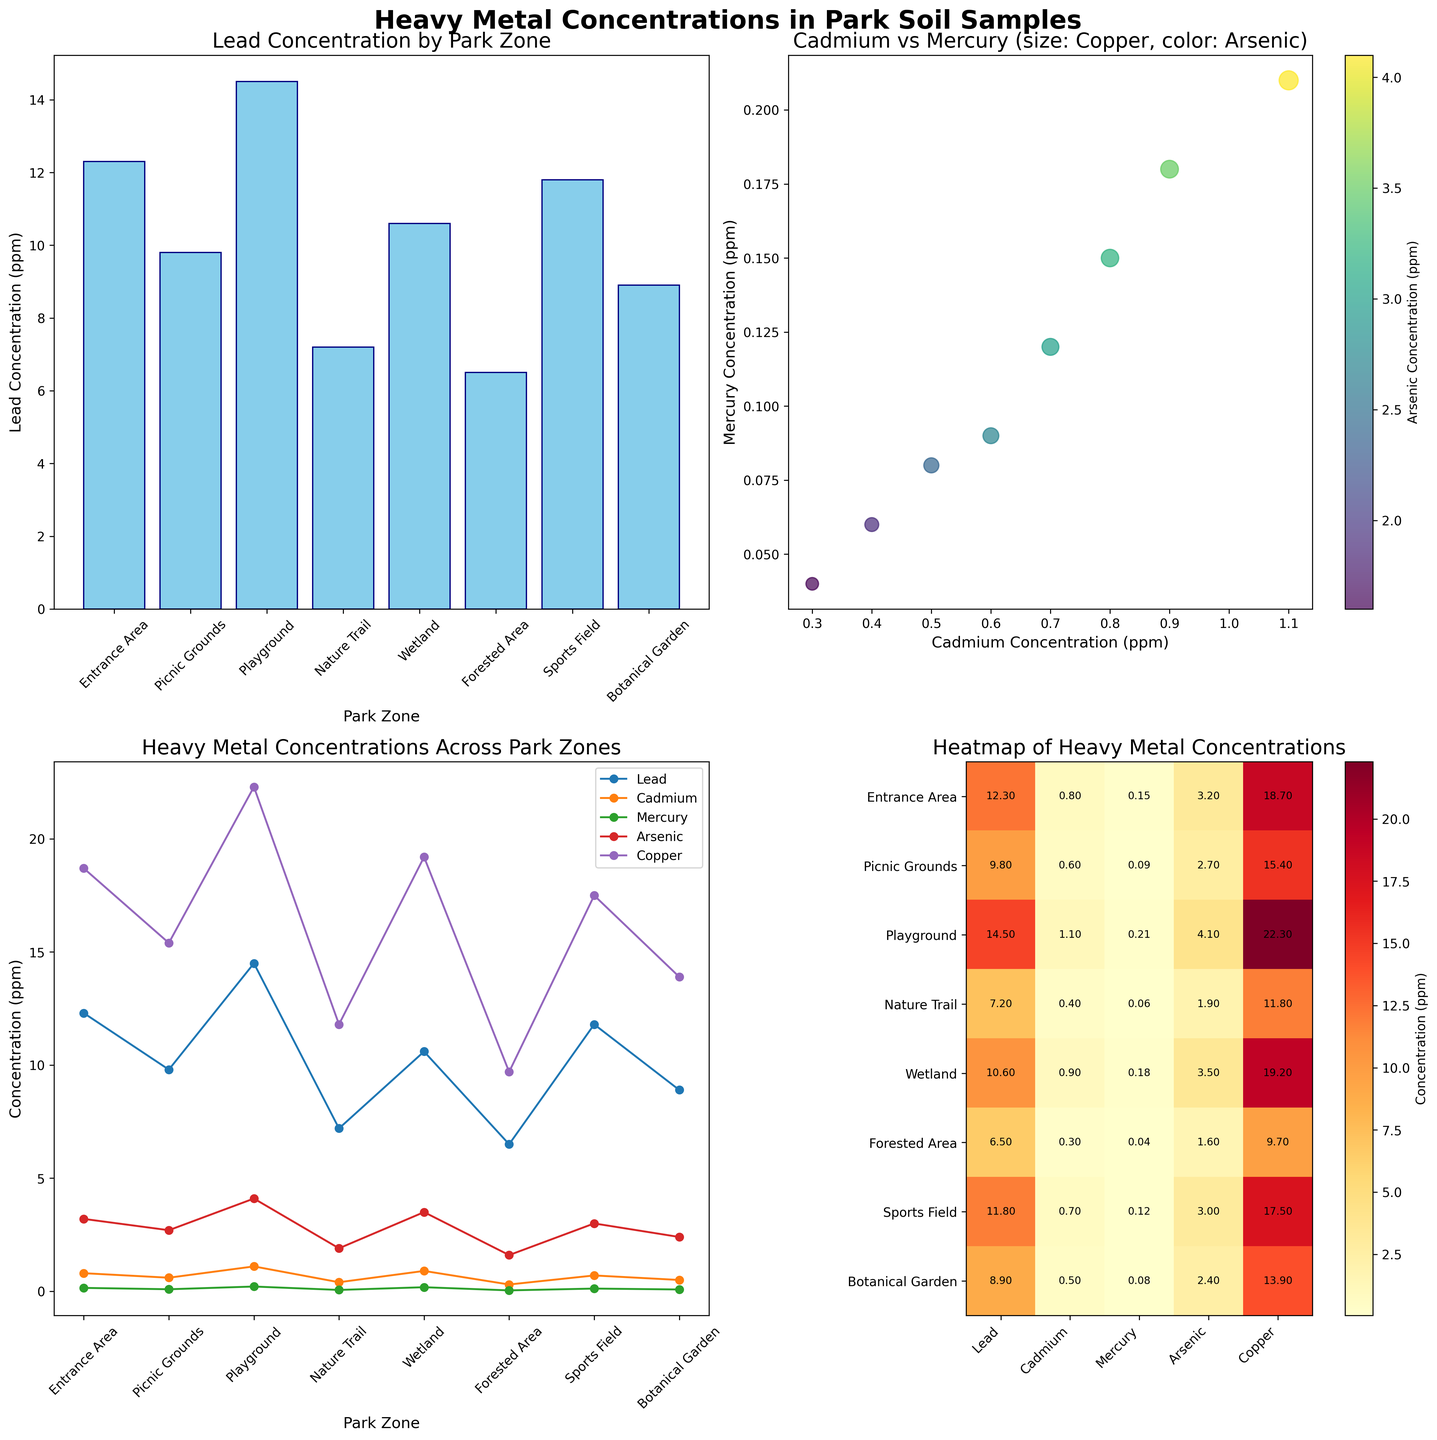what is the title of the top left subplot? The title of the top left subplot is placed at the top of the chart, within that subplot’s frame. It reads 'Lead Concentration by Park Zone'.
Answer: Lead Concentration by Park Zone Which park zone has the highest lead concentration? From the bar plot in the top left subplot, we see that the Playground has the tallest bar indicating it has the highest value.
Answer: Playground What are the x-axis labels of the heatmap in the bottom right subplot? The x-axis labels of the heatmap, representing different heavy metals, are displayed along the bottom axis. They read as Lead, Cadmium, Mercury, Arsenic, and Copper.
Answer: Lead, Cadmium, Mercury, Arsenic, Copper What is the range of arsenic concentration across all park zones? In the scatter plot at the top right, the color bar represents the arsenic concentration. Checking the color scale and the points on the scatter plot, we can infer that arsenic concentrations range from around 1.6 to 4.1 ppm.
Answer: 1.6 to 4.1 ppm Which two zones have the closest cadmium concentrations? From the line plot in the bottom left subplot, Nature Trail and Botanical Garden have lines that intersect closely around 0.4 and 0.5 ppm respectively, indicating closest values for cadmium concentration.
Answer: Nature Trail, Botanical Garden In which park zones are lead concentrations above 10 ppm? In the top left bar plot, the bars for Entrance Area, Playground, and Sports Field exceed the 10 ppm mark on the y-axis for lead concentration.
Answer: Entrance Area, Playground, Sports Field Which metal has the highest variability in concentration across park zones, according to the line plot? Comparing the spread of each line in the bottom left subplot, the blue line (Lead) shows the most variation, covering the widest range from 6.5 to 14.5 ppm.
Answer: Lead What is the relationship between cadmium and mercury concentrations based on their scatter plot? In the top right subplot, increases in cadmium concentration correlate with increases in mercury concentration, indicating a positive relationship.
Answer: Positive relationship How does the concentration of heavy metals in the Forested Area compare to the Wetland according to the heatmap? In the bottom right subplot, comparing data values, Forested Area has lower concentrations of all heavy metals compared to Wetland (6.5 vs 10.6 for Lead, 0.3 vs 0.9 for Cadmium, 0.04 vs 0.18 for Mercury, 1.6 vs 3.5 for Arsenic, and 9.7 vs 19.2 for Copper).
Answer: Lower in all heavy metals Which park zone appears to have the least overall heavy metal contamination based on the heatmap? In the bottom right subplot, the Forested Area exhibits the lowest values in all heavy metals, indicating the least contamination.
Answer: Forested Area 